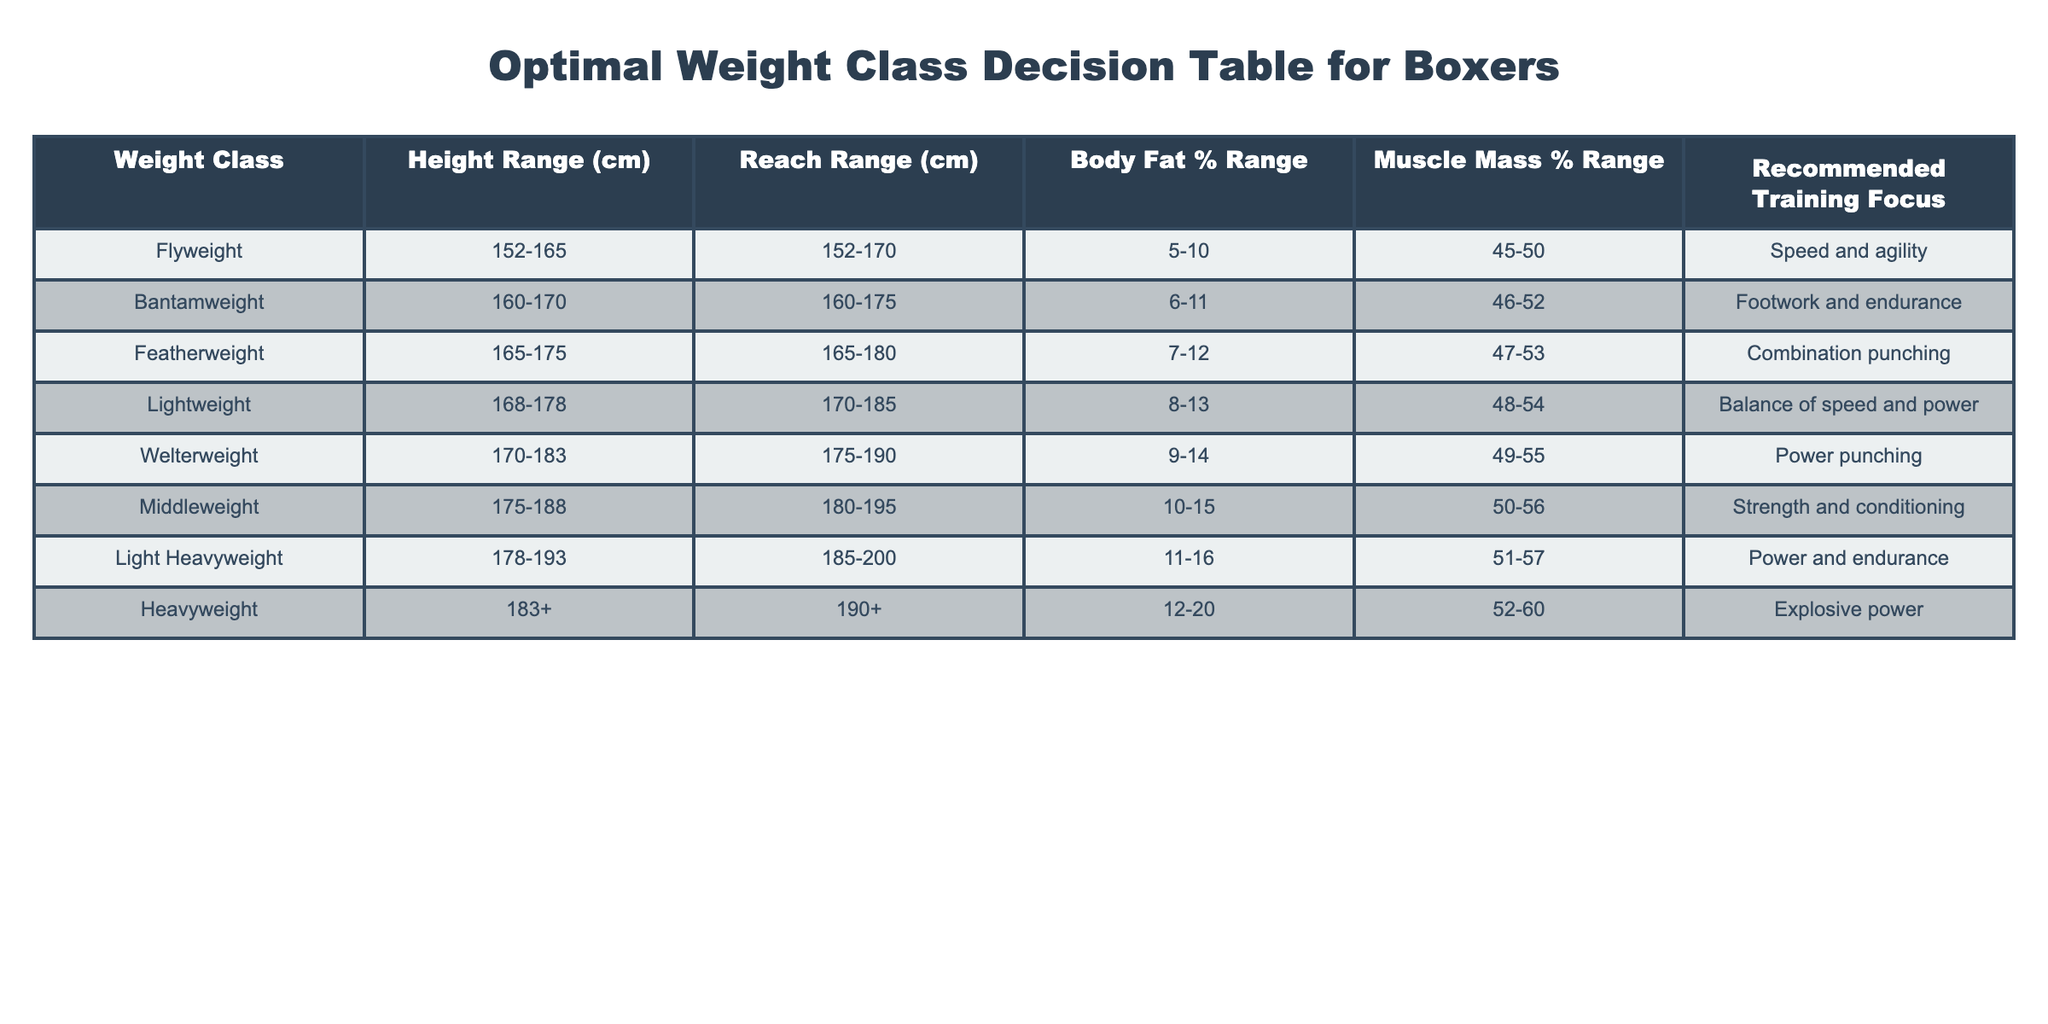What is the height range for the Welterweight class? The table lists the height range for the Welterweight class under the "Height Range (cm)" column, which shows the range as 170-183 cm.
Answer: 170-183 cm Which weight class has the highest recommended training focus on endurance? By checking the "Recommended Training Focus" column, the Light Heavyweight class is focused on power and endurance, making it the one with the highest emphasis on endurance among the listed classes.
Answer: Light Heavyweight What is the average body fat percentage range for the Middleweight and Light Heavyweight classes? The body fat percentage ranges for Middleweight and Light Heavyweight are 10-15 and 11-16 respectively. To find the average of these ranges, take the midpoints (12.5 and 13.5), which averages to 13%.
Answer: 13% Is the Featherweight class focused more on combination punching compared to the Welterweight class, which emphasizes power punching? The Featherweight class is associated with combination punching according to the table, while the Welterweight class emphasizes power punching. These are different training focuses, but in terms of general versatility, combination punching can be considered a broader approach than pure power punching. Thus, one could argue that Featherweight focuses on a more diverse set of skills compared to Welterweight.
Answer: Yes What is the difference in muscle mass percentage range between the Bantamweight and Lightweight classes? The Bantamweight class has a muscle mass percentage range of 46-52%, while the Lightweight class has a range of 48-54%. To find the difference, calculate the range of each class (52 - 46 = 6 for Bantamweight and 54 - 48 = 6 for Lightweight). Since the ranges are the same, the difference is zero.
Answer: 0% 